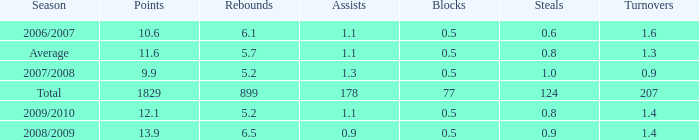What is the maximum rebounds when there are 0.9 steals and fewer than 1.4 turnovers? None. 